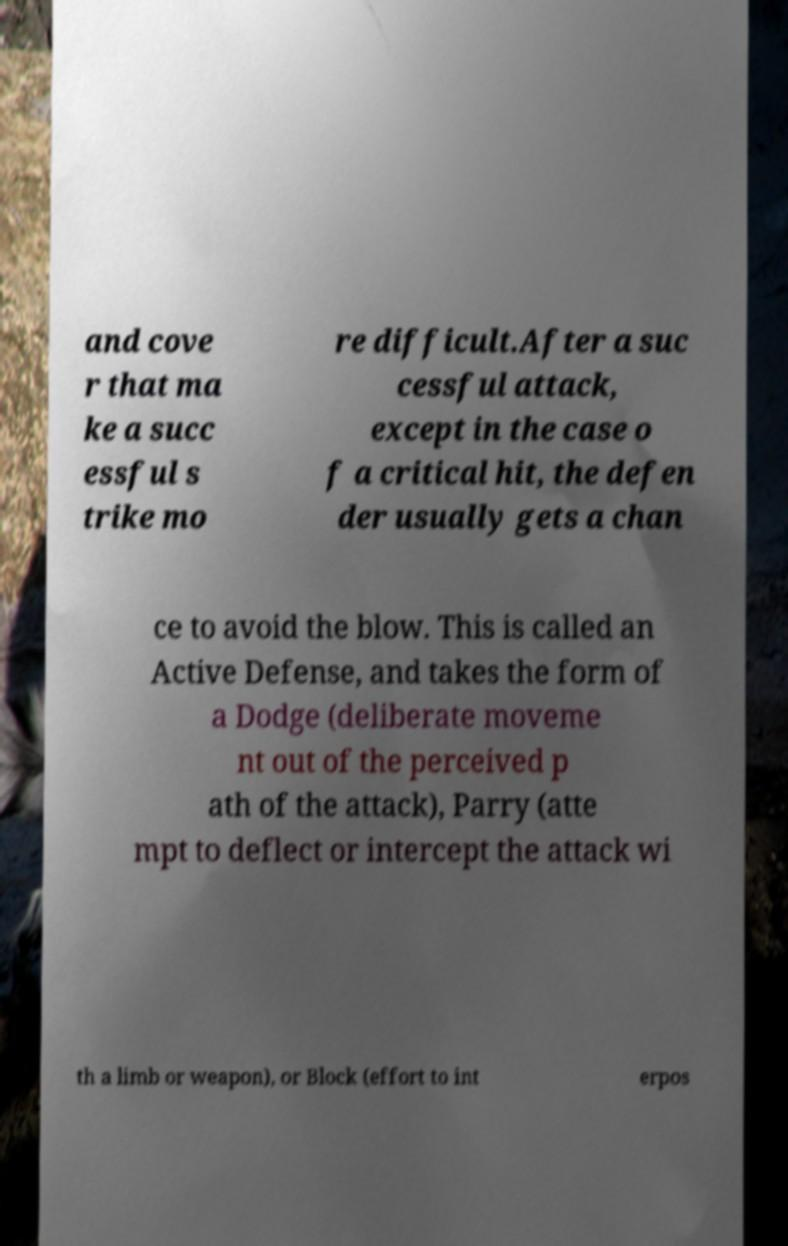What messages or text are displayed in this image? I need them in a readable, typed format. and cove r that ma ke a succ essful s trike mo re difficult.After a suc cessful attack, except in the case o f a critical hit, the defen der usually gets a chan ce to avoid the blow. This is called an Active Defense, and takes the form of a Dodge (deliberate moveme nt out of the perceived p ath of the attack), Parry (atte mpt to deflect or intercept the attack wi th a limb or weapon), or Block (effort to int erpos 